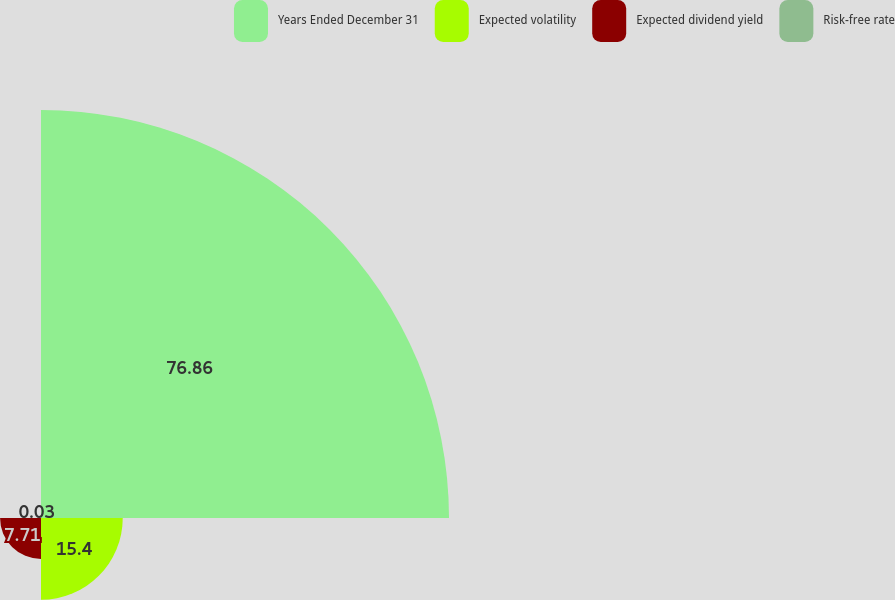Convert chart. <chart><loc_0><loc_0><loc_500><loc_500><pie_chart><fcel>Years Ended December 31<fcel>Expected volatility<fcel>Expected dividend yield<fcel>Risk-free rate<nl><fcel>76.86%<fcel>15.4%<fcel>7.71%<fcel>0.03%<nl></chart> 